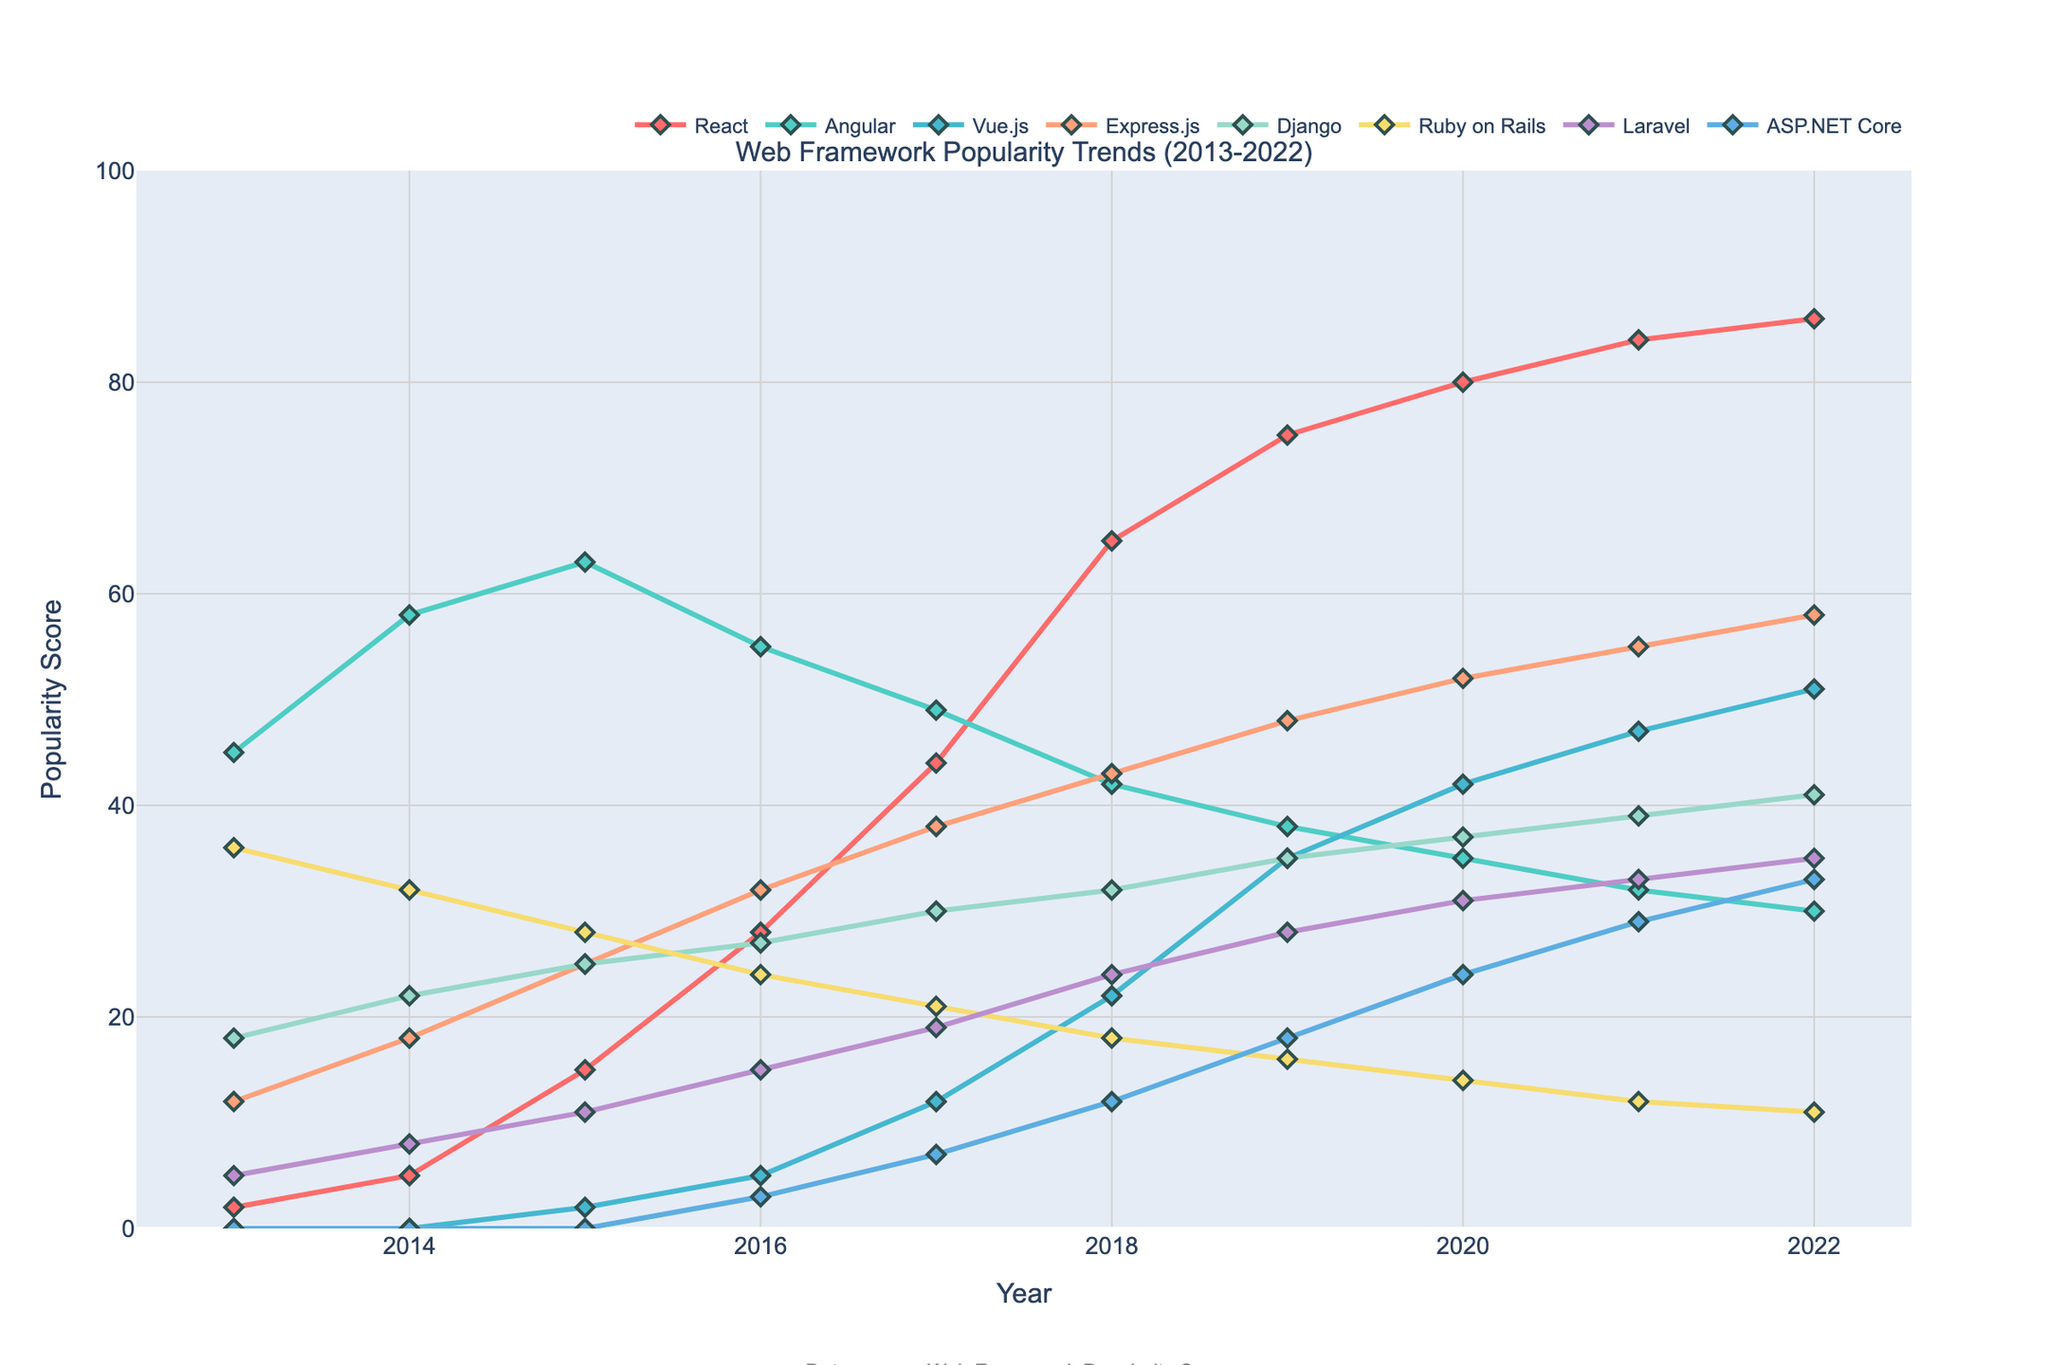What's the most popular web framework in 2022? Look at the last data point (2022) for each framework. The highest value is for React.
Answer: React Which web framework showed the highest overall increase in popularity from 2013 to 2022? Subtract the 2013 values from the 2022 values for each framework. The framework with the largest difference is React (86-2 = 84).
Answer: React Between 2016 and 2018, which framework experienced the largest drop in popularity? Compare the values for each framework between 2016 and 2018. Angular dropped from 55 to 42, which is the largest decrease of 13.
Answer: Angular What's the average popularity score of Django over the decade? Sum the popularity scores of Django from 2013 to 2022 and divide by 10 ((18+22+25+27+30+32+35+37+39+41)/10). The average is 30.6.
Answer: 30.6 Which two frameworks had a popularity score of 0 at some point during the decade? Look for any years where the popularity score is 0. Vue.js and ASP.NET Core had a score of 0 in 2013 and 2014, and ASP.NET Core had a score of 0 from 2013 to 2015.
Answer: Vue.js, ASP.NET Core What's the total increase in popularity for Vue.js from 2013 to 2022? Subtract the 2013 value from 2022 for Vue.js. The increase is (51-0=51).
Answer: 51 Which framework was the least popular in 2017? Look at the values for 2017, the lowest value is for ASP.NET Core with a score of 7.
Answer: ASP.NET Core How did the popularity of Laravel change from 2015 to 2020? Compare the values for 2015 and 2020 for Laravel. It increased from 11 to 31. The increase is (31-11=20).
Answer: Increased by 20 Which framework's popularity remained relatively stable throughout the decade, changing less than 15 points? Look at the changes for each framework from 2013 to 2022. Ruby on Rails' popularity shows the smallest variation, decreasing from 36 to 11, a change of 25, the next smallest change is for Express.js, increasing 46 points.
Answer: None In which year did React surpass Angular in popularity? Compare the values of React and Angular year-by-year. React surpasses Angular in 2017 (44 vs 49, and 65 vs 42 in 2018).
Answer: 2018 